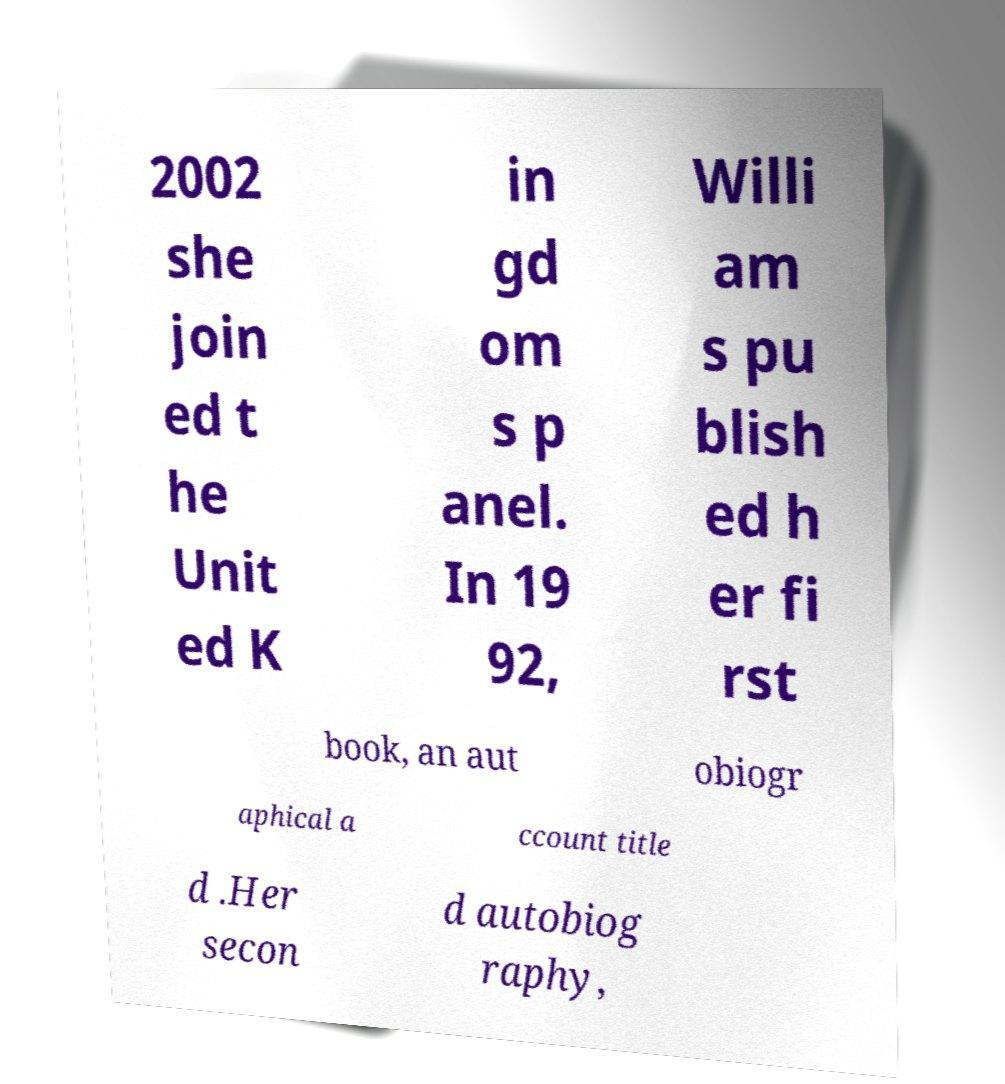Can you accurately transcribe the text from the provided image for me? 2002 she join ed t he Unit ed K in gd om s p anel. In 19 92, Willi am s pu blish ed h er fi rst book, an aut obiogr aphical a ccount title d .Her secon d autobiog raphy, 